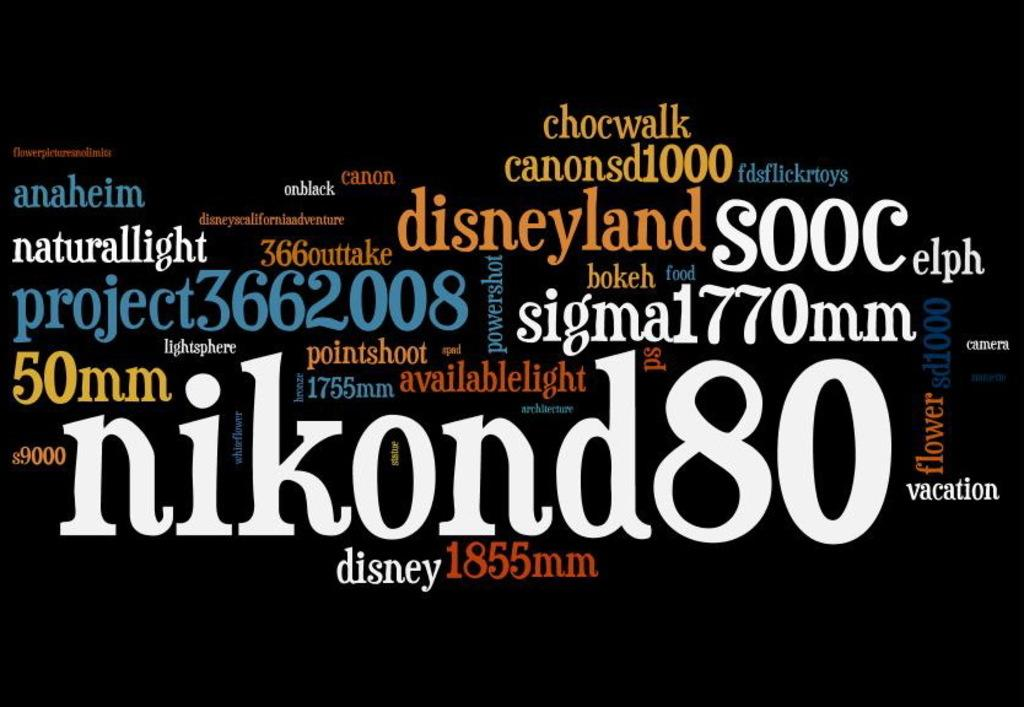Provide a one-sentence caption for the provided image. A collection of different texts in the same font but different colors read phrases like "disneyland", "chocwalk", and "naturallight" among many others. 